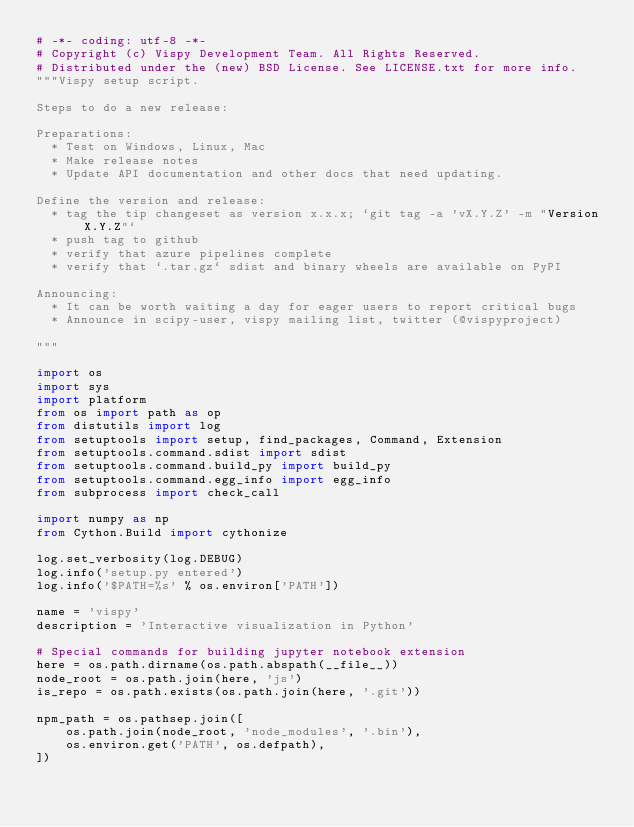<code> <loc_0><loc_0><loc_500><loc_500><_Python_># -*- coding: utf-8 -*-
# Copyright (c) Vispy Development Team. All Rights Reserved.
# Distributed under the (new) BSD License. See LICENSE.txt for more info.
"""Vispy setup script.

Steps to do a new release:

Preparations:
  * Test on Windows, Linux, Mac
  * Make release notes
  * Update API documentation and other docs that need updating.

Define the version and release:
  * tag the tip changeset as version x.x.x; `git tag -a 'vX.Y.Z' -m "Version X.Y.Z"`
  * push tag to github
  * verify that azure pipelines complete
  * verify that `.tar.gz` sdist and binary wheels are available on PyPI

Announcing:
  * It can be worth waiting a day for eager users to report critical bugs
  * Announce in scipy-user, vispy mailing list, twitter (@vispyproject)

"""

import os
import sys
import platform
from os import path as op
from distutils import log
from setuptools import setup, find_packages, Command, Extension
from setuptools.command.sdist import sdist
from setuptools.command.build_py import build_py
from setuptools.command.egg_info import egg_info
from subprocess import check_call

import numpy as np
from Cython.Build import cythonize

log.set_verbosity(log.DEBUG)
log.info('setup.py entered')
log.info('$PATH=%s' % os.environ['PATH'])

name = 'vispy'
description = 'Interactive visualization in Python'

# Special commands for building jupyter notebook extension
here = os.path.dirname(os.path.abspath(__file__))
node_root = os.path.join(here, 'js')
is_repo = os.path.exists(os.path.join(here, '.git'))

npm_path = os.pathsep.join([
    os.path.join(node_root, 'node_modules', '.bin'),
    os.environ.get('PATH', os.defpath),
])

</code> 